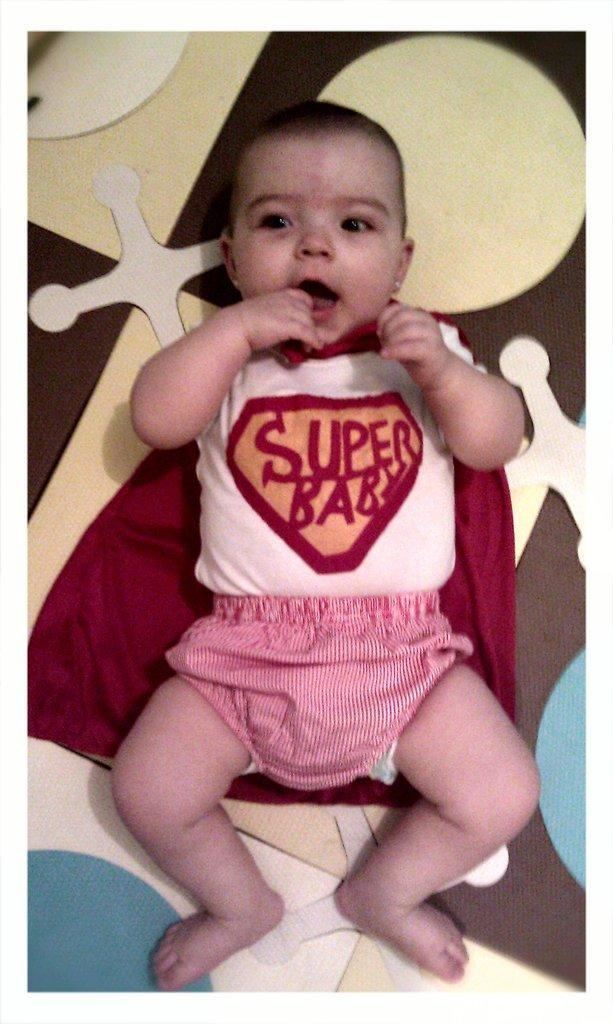What is the main subject of the picture? The main subject of the picture is a baby. What is the baby doing in the picture? The baby is lying on the bed and smiling. What can be seen in the background of the image? The background of the image has white, yellow, brown, and blue colors, which might be from a bed sheet. What type of oatmeal can be seen in the background of the image? There is no oatmeal present in the image; the background colors are likely from a bed sheet. What part of the cave is visible in the image? There is no cave present in the image; it features a baby lying on a bed. 